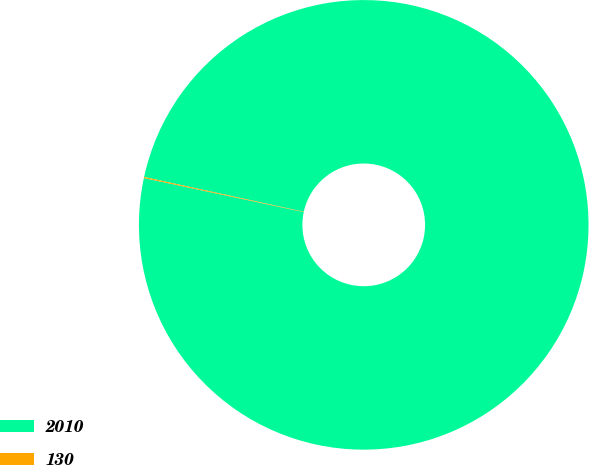Convert chart. <chart><loc_0><loc_0><loc_500><loc_500><pie_chart><fcel>2010<fcel>130<nl><fcel>99.92%<fcel>0.08%<nl></chart> 